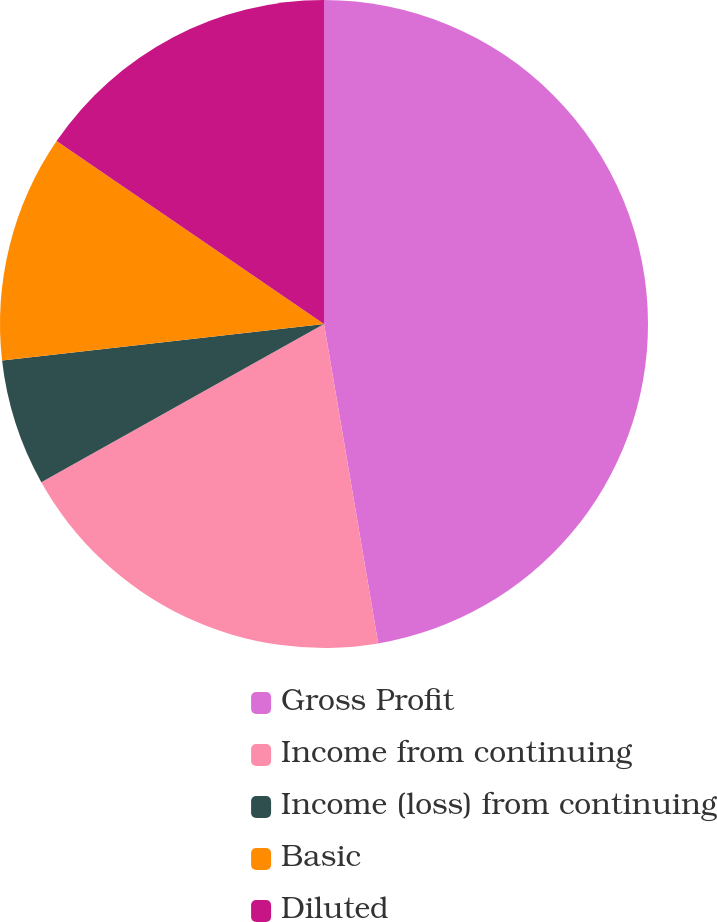Convert chart. <chart><loc_0><loc_0><loc_500><loc_500><pie_chart><fcel>Gross Profit<fcel>Income from continuing<fcel>Income (loss) from continuing<fcel>Basic<fcel>Diluted<nl><fcel>47.32%<fcel>19.55%<fcel>6.32%<fcel>11.35%<fcel>15.45%<nl></chart> 